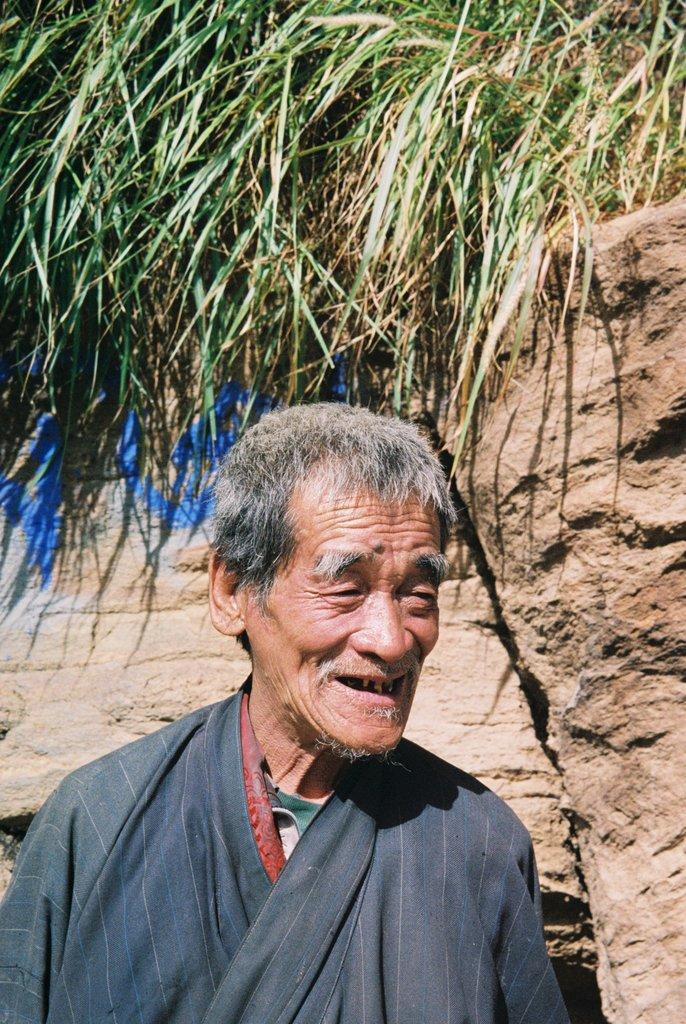What is the main subject of the image? There is a man in the image. What is the man wearing? The man is wearing a black dress. What is the man's facial expression? The man is smiling. What can be seen in the background of the image? There is grass visible in the background of the image, as well as an unspecified object. What verse is the man reciting in the image? There is no indication in the image that the man is reciting a verse, so it cannot be determined from the picture. 